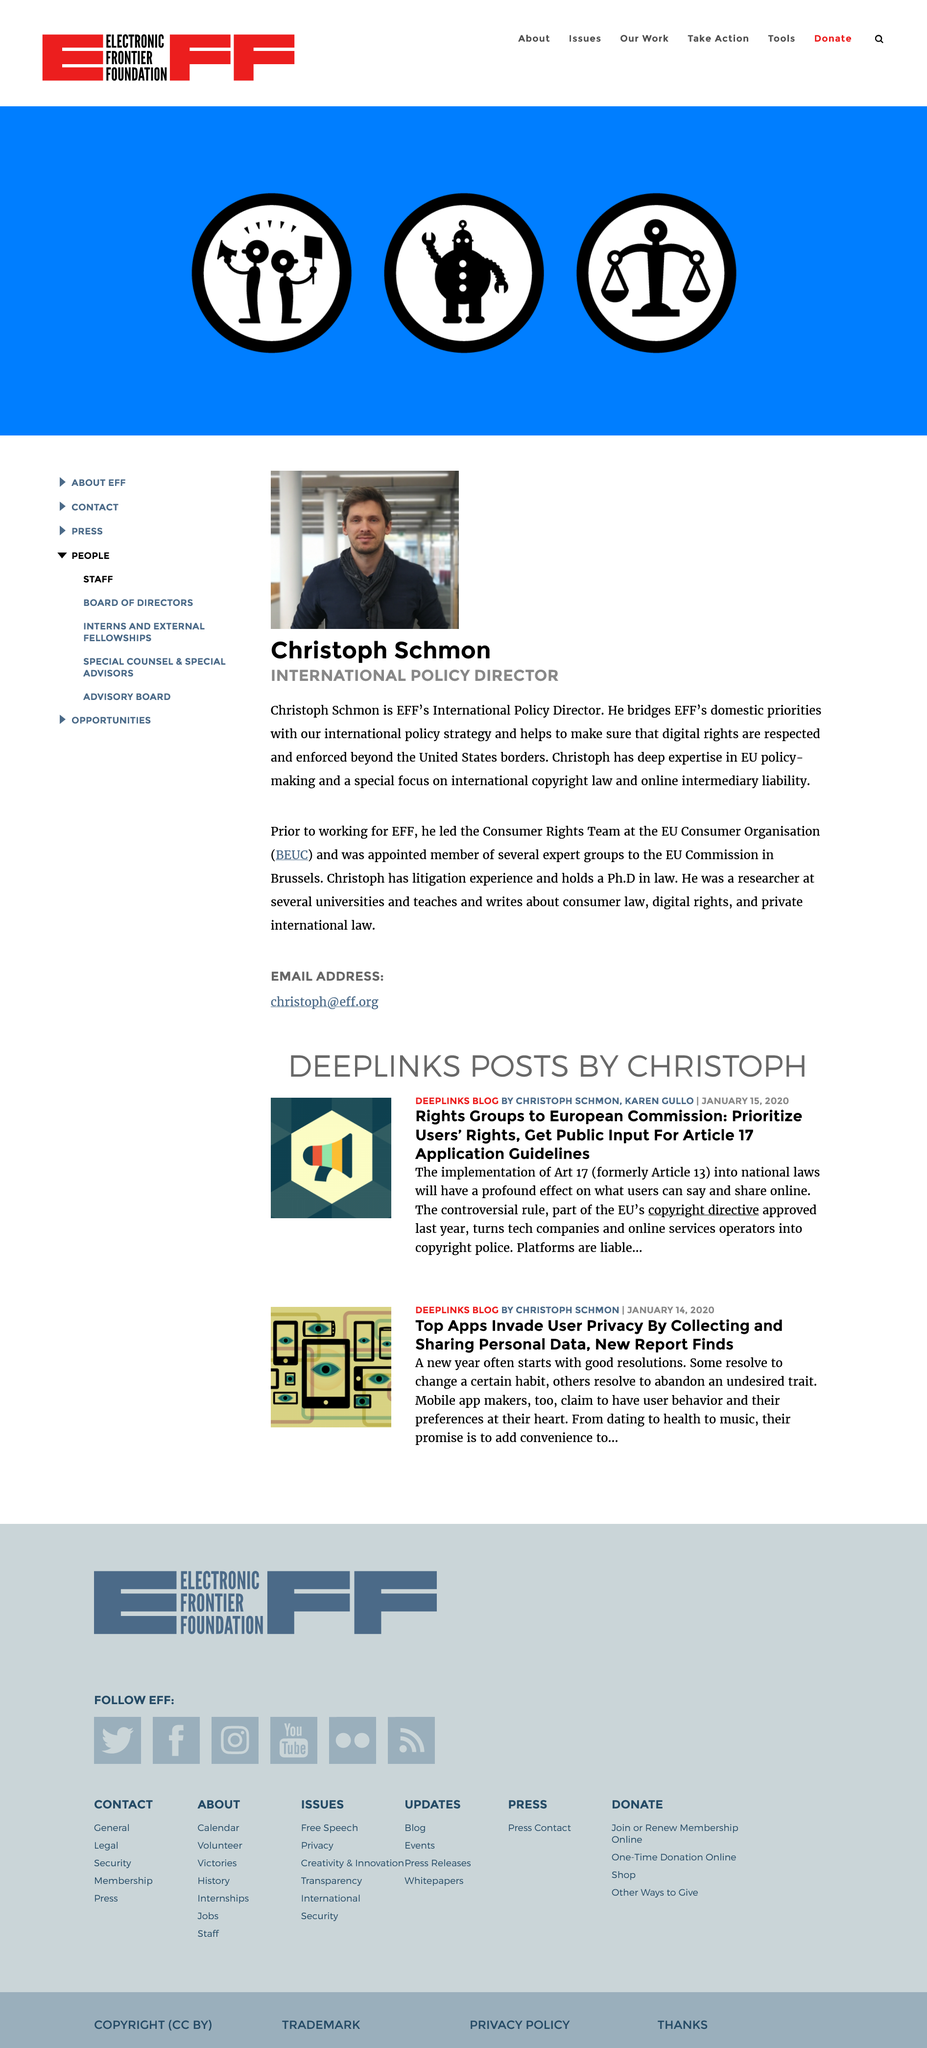Outline some significant characteristics in this image. Christoph Schmon is the International Policy Director for the Electronic Frontier Foundation (EFF). Yes, EFF's International Policy Director holds a Ph.D in law. Christoph Schmon is responsible for aligning EFF's domestic priorities with their international policy strategy. 